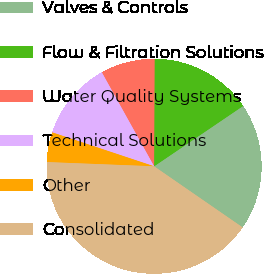<chart> <loc_0><loc_0><loc_500><loc_500><pie_chart><fcel>Valves & Controls<fcel>Flow & Filtration Solutions<fcel>Water Quality Systems<fcel>Technical Solutions<fcel>Other<fcel>Consolidated<nl><fcel>19.1%<fcel>15.45%<fcel>8.15%<fcel>11.8%<fcel>4.49%<fcel>41.01%<nl></chart> 